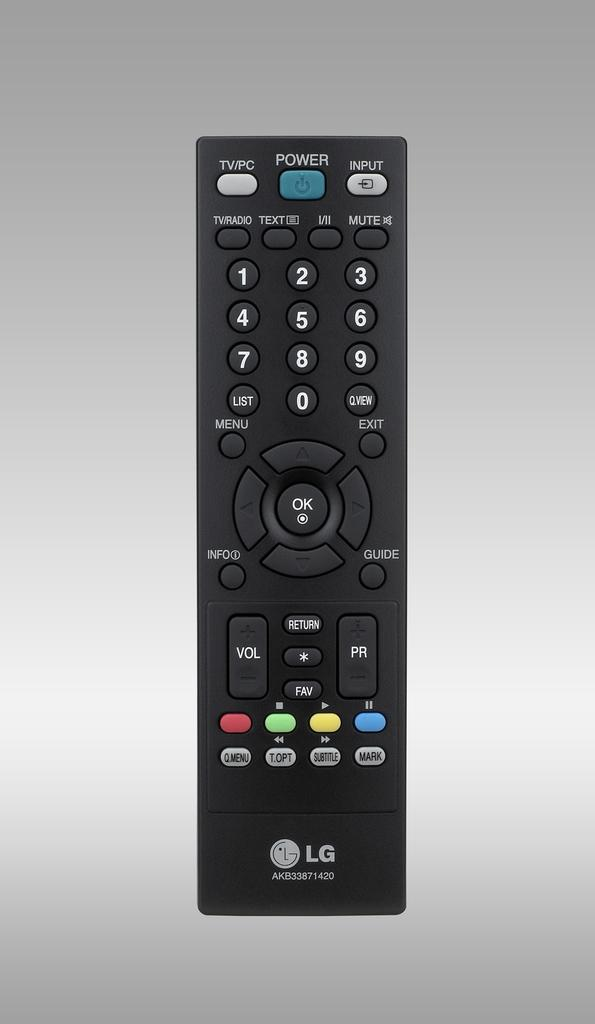<image>
Relay a brief, clear account of the picture shown. A black LG remote with a blue Power button. 